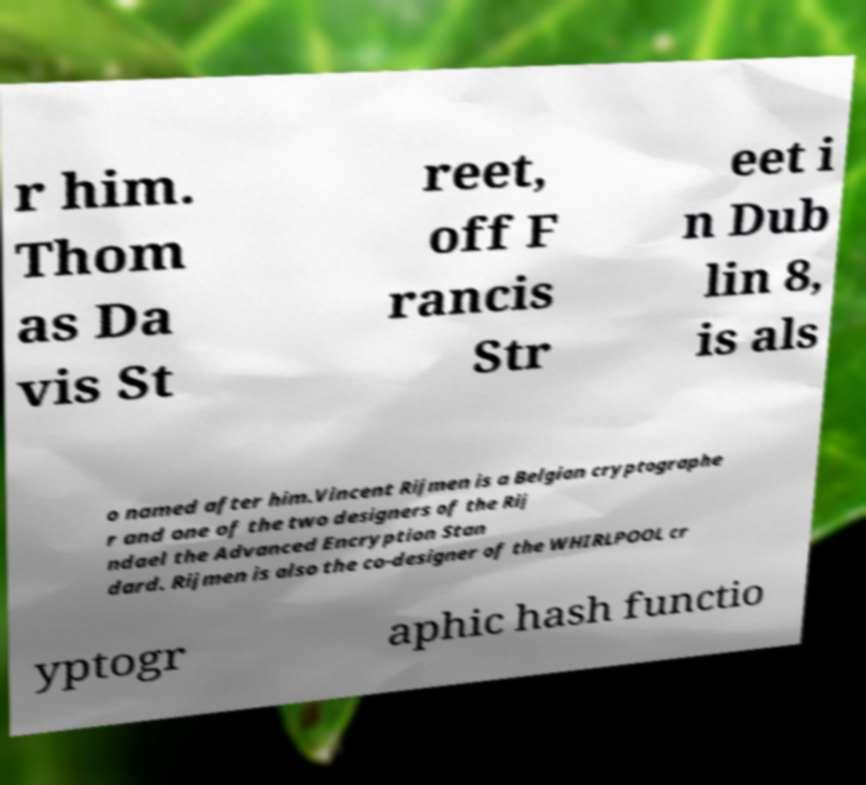Can you accurately transcribe the text from the provided image for me? r him. Thom as Da vis St reet, off F rancis Str eet i n Dub lin 8, is als o named after him.Vincent Rijmen is a Belgian cryptographe r and one of the two designers of the Rij ndael the Advanced Encryption Stan dard. Rijmen is also the co-designer of the WHIRLPOOL cr yptogr aphic hash functio 